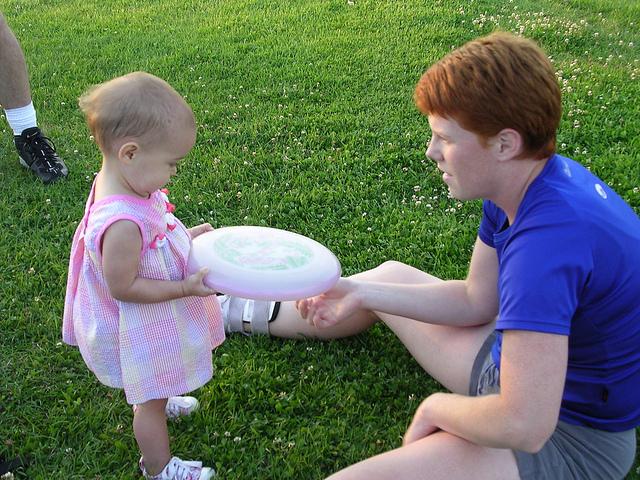Which person will likely throw the Frisbee more skillfully?
Answer briefly. Boy. What are they both holding?
Write a very short answer. Frisbee. Is the child wearing shorts?
Keep it brief. No. 